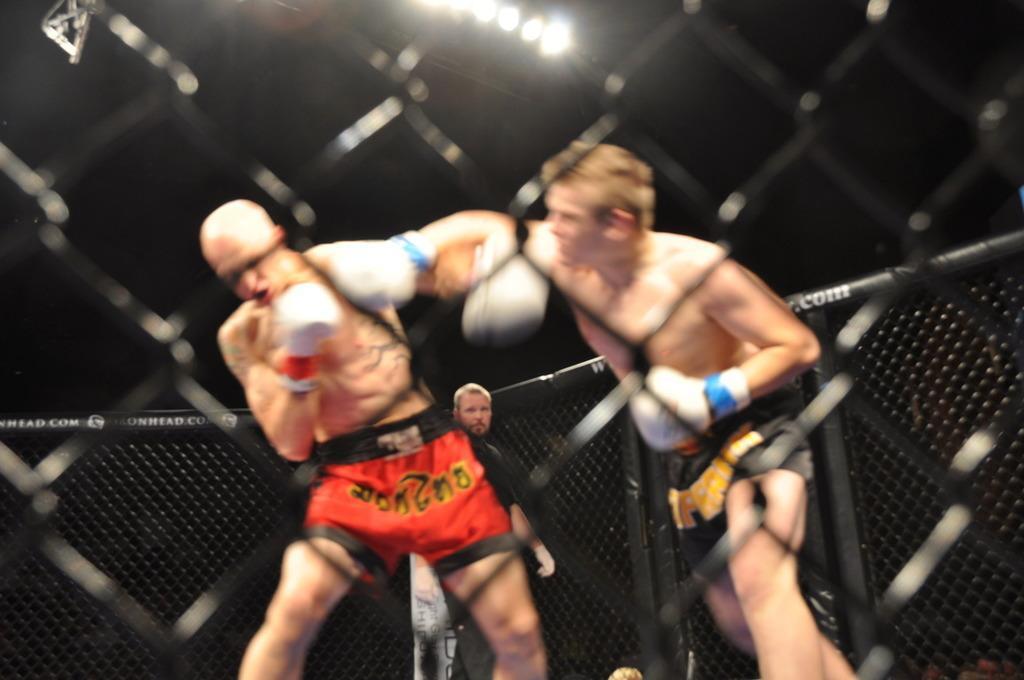Can you describe this image briefly? In the center of the image there is a fence. Through the fence, we can see two persons are boxing and they are in different costumes. In the background there is a fence, lights, one person is standing and a few other objects. 